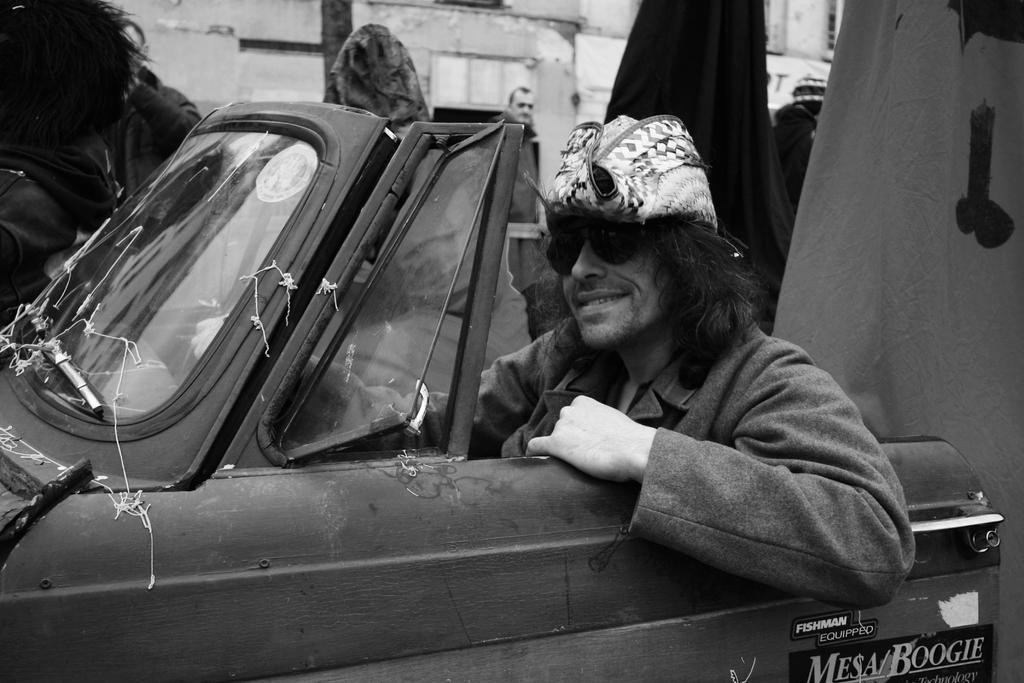How would you summarize this image in a sentence or two? In this picture we can see a person in a vehicle and in the background we can see persons. 